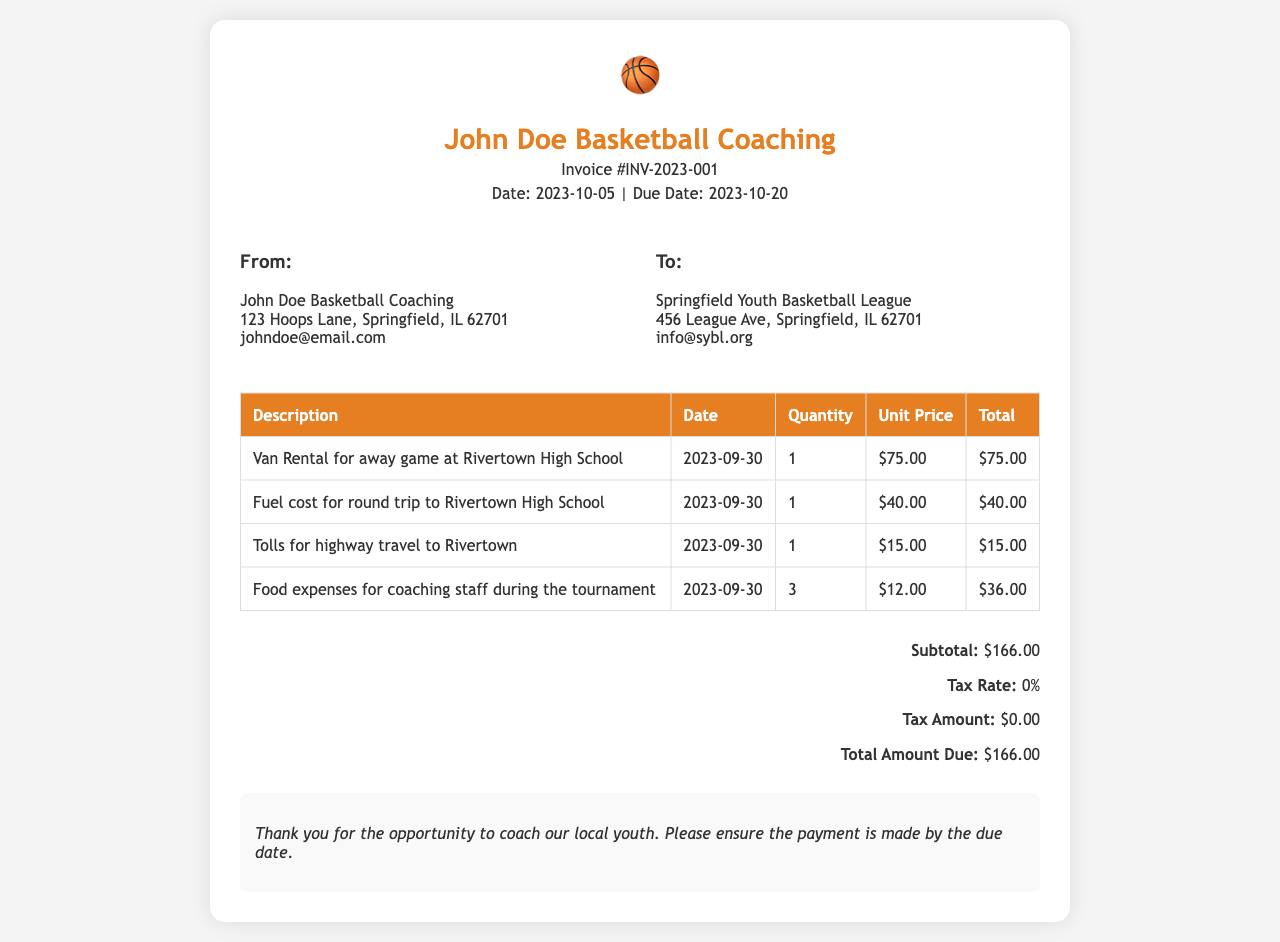What is the invoice number? The invoice number is indicated clearly in the document as Invoice #INV-2023-001.
Answer: INV-2023-001 What is the due date for the invoice? The due date is listed on the document as 2023-10-20.
Answer: 2023-10-20 Who is the recipient of the invoice? The recipient is mentioned in the "To" section as Springfield Youth Basketball League.
Answer: Springfield Youth Basketball League What is the total amount due? The total amount due is presented in the summary section as $166.00.
Answer: $166.00 How many food expenses were accounted for in the invoice? The food expenses are listed with a quantity of 3 in the itemized section.
Answer: 3 What date was the van rental incurred? The date for the van rental is specified as 2023-09-30.
Answer: 2023-09-30 What was the subtotal before tax? The subtotal before tax is shown as $166.00 in the summary section.
Answer: $166.00 What is the tax rate applied in this invoice? The tax rate is indicated as 0% in the summary section of the document.
Answer: 0% What kind of expenses does this invoice cover? The expenses covered in this invoice are related to transportation for organizing away games or tournaments.
Answer: Transportation expenses 